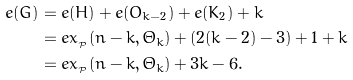Convert formula to latex. <formula><loc_0><loc_0><loc_500><loc_500>e ( G ) & = e ( H ) + e ( O _ { k - 2 } ) + e ( K _ { 2 } ) + k \\ & = e x _ { _ { \mathcal { P } } } ( n - k , \Theta _ { k } ) + ( 2 ( k - 2 ) - 3 ) + 1 + k \\ & = e x _ { _ { \mathcal { P } } } ( n - k , \Theta _ { k } ) + 3 k - 6 .</formula> 